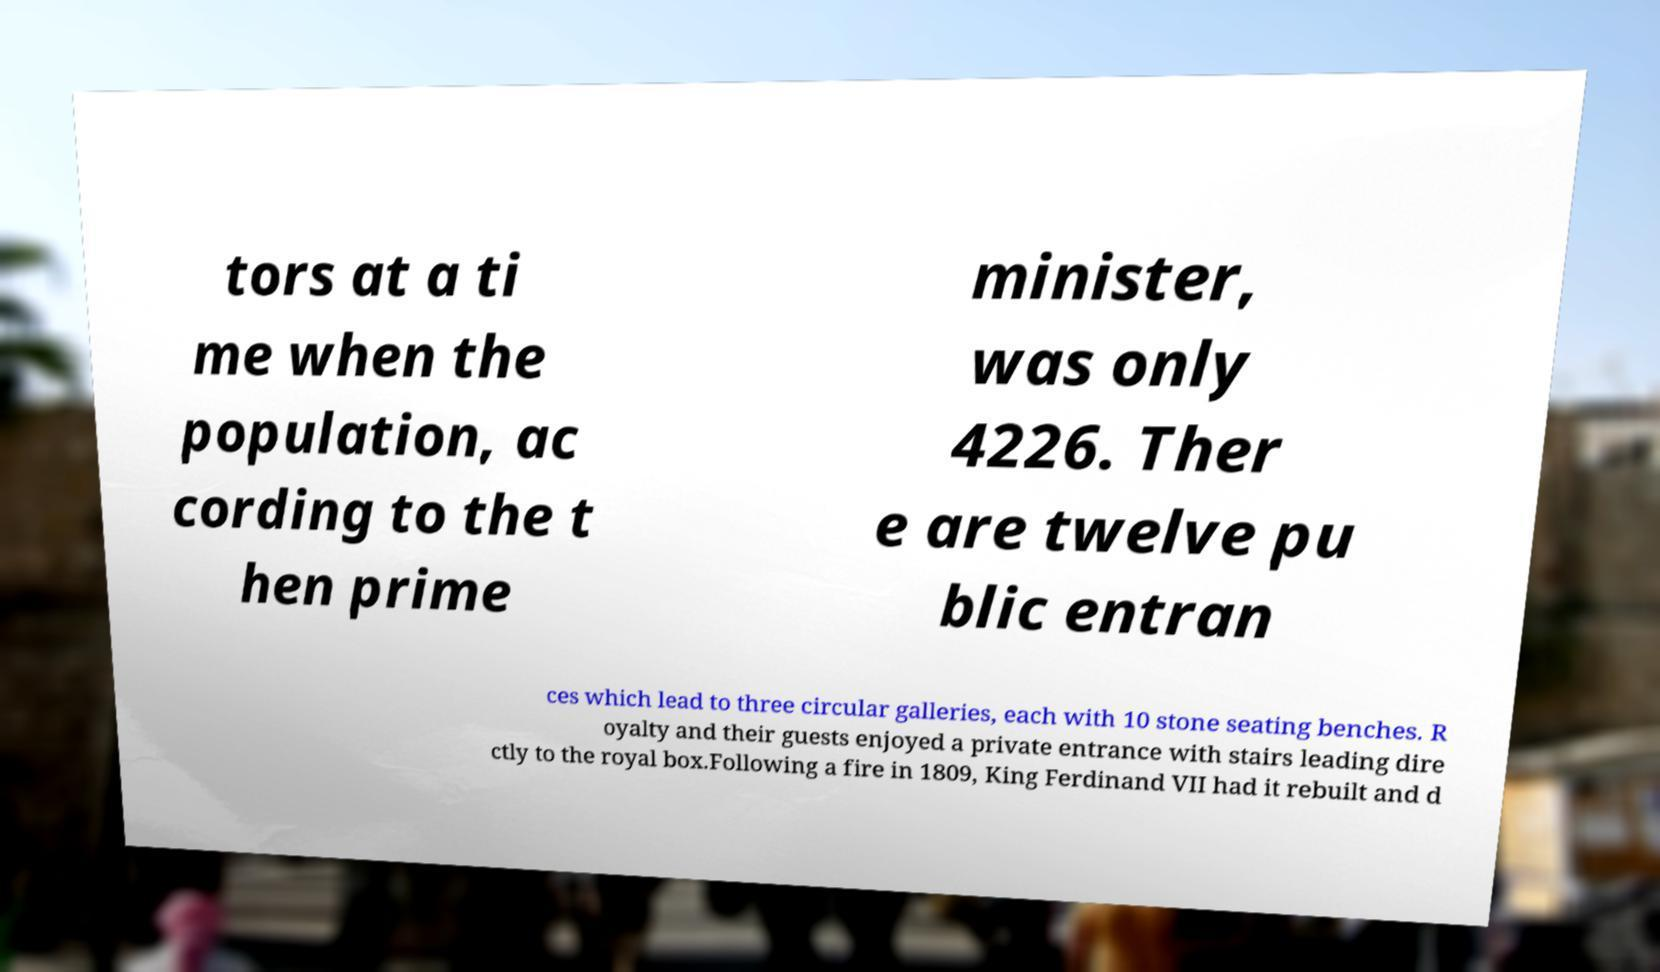Could you assist in decoding the text presented in this image and type it out clearly? tors at a ti me when the population, ac cording to the t hen prime minister, was only 4226. Ther e are twelve pu blic entran ces which lead to three circular galleries, each with 10 stone seating benches. R oyalty and their guests enjoyed a private entrance with stairs leading dire ctly to the royal box.Following a fire in 1809, King Ferdinand VII had it rebuilt and d 